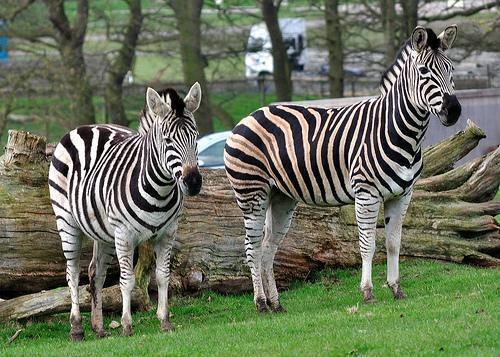How many animals are seen?
Give a very brief answer. 2. How many zebra legs are visible?
Give a very brief answer. 8. 